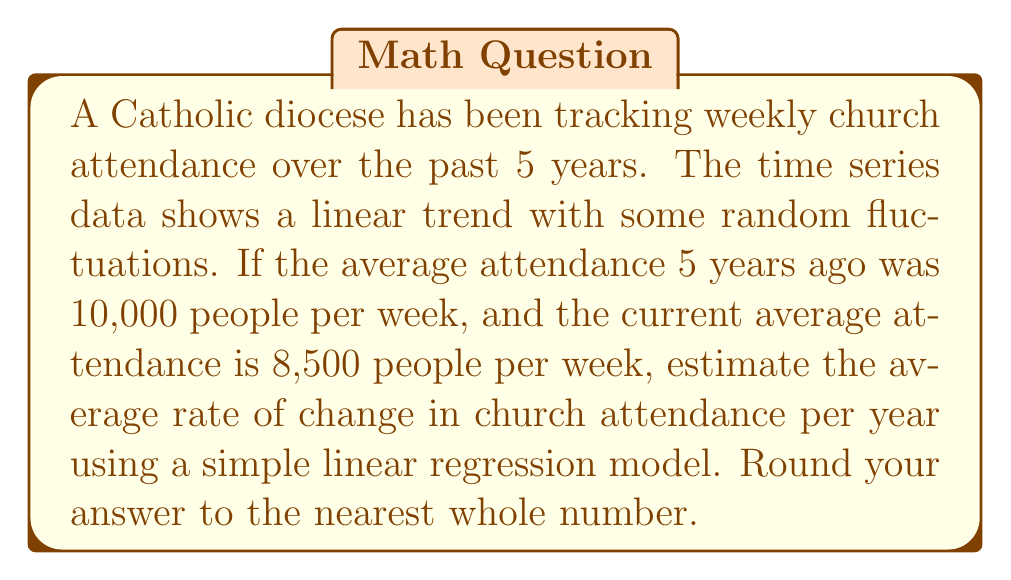Could you help me with this problem? To estimate the rate of change in church attendance using time series analysis, we'll use a simple linear regression model:

1. Define variables:
   $y_t$ = church attendance at time $t$
   $t$ = time in years (0 to 5)
   $\beta_0$ = y-intercept (initial attendance)
   $\beta_1$ = slope (annual rate of change)

2. Set up the linear model:
   $y_t = \beta_0 + \beta_1t + \epsilon_t$

3. We know two points:
   At $t=0$, $y_0 = 10,000$
   At $t=5$, $y_5 = 8,500$

4. Calculate the slope $\beta_1$:
   $$\beta_1 = \frac{y_5 - y_0}{5-0} = \frac{8,500 - 10,000}{5} = -300$$

5. The slope $\beta_1$ represents the average annual rate of change in church attendance.

6. Round to the nearest whole number: -300
Answer: -300 people per year 